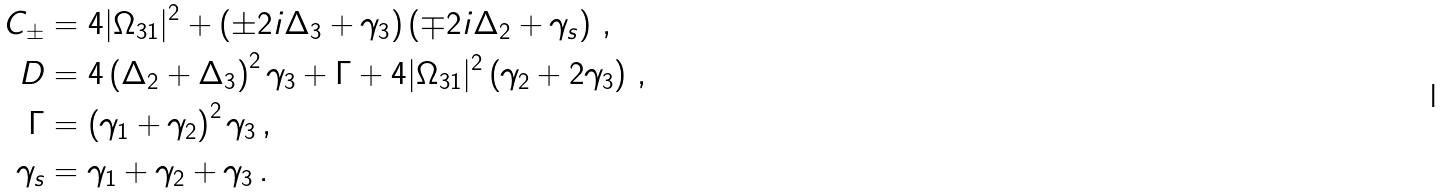<formula> <loc_0><loc_0><loc_500><loc_500>C _ { \pm } & = 4 | \Omega _ { 3 1 } | ^ { 2 } + \left ( \pm 2 i \Delta _ { 3 } + \gamma _ { 3 } \right ) \left ( \mp 2 i \Delta _ { 2 } + \gamma _ { s } \right ) \, , \\ D & = 4 \left ( \Delta _ { 2 } + \Delta _ { 3 } \right ) ^ { 2 } \gamma _ { 3 } + \Gamma + 4 | \Omega _ { 3 1 } | ^ { 2 } \left ( \gamma _ { 2 } + 2 \gamma _ { 3 } \right ) \, , \\ \Gamma & = \left ( \gamma _ { 1 } + \gamma _ { 2 } \right ) ^ { 2 } \gamma _ { 3 } \, , \\ \gamma _ { s } & = \gamma _ { 1 } + \gamma _ { 2 } + \gamma _ { 3 } \, .</formula> 